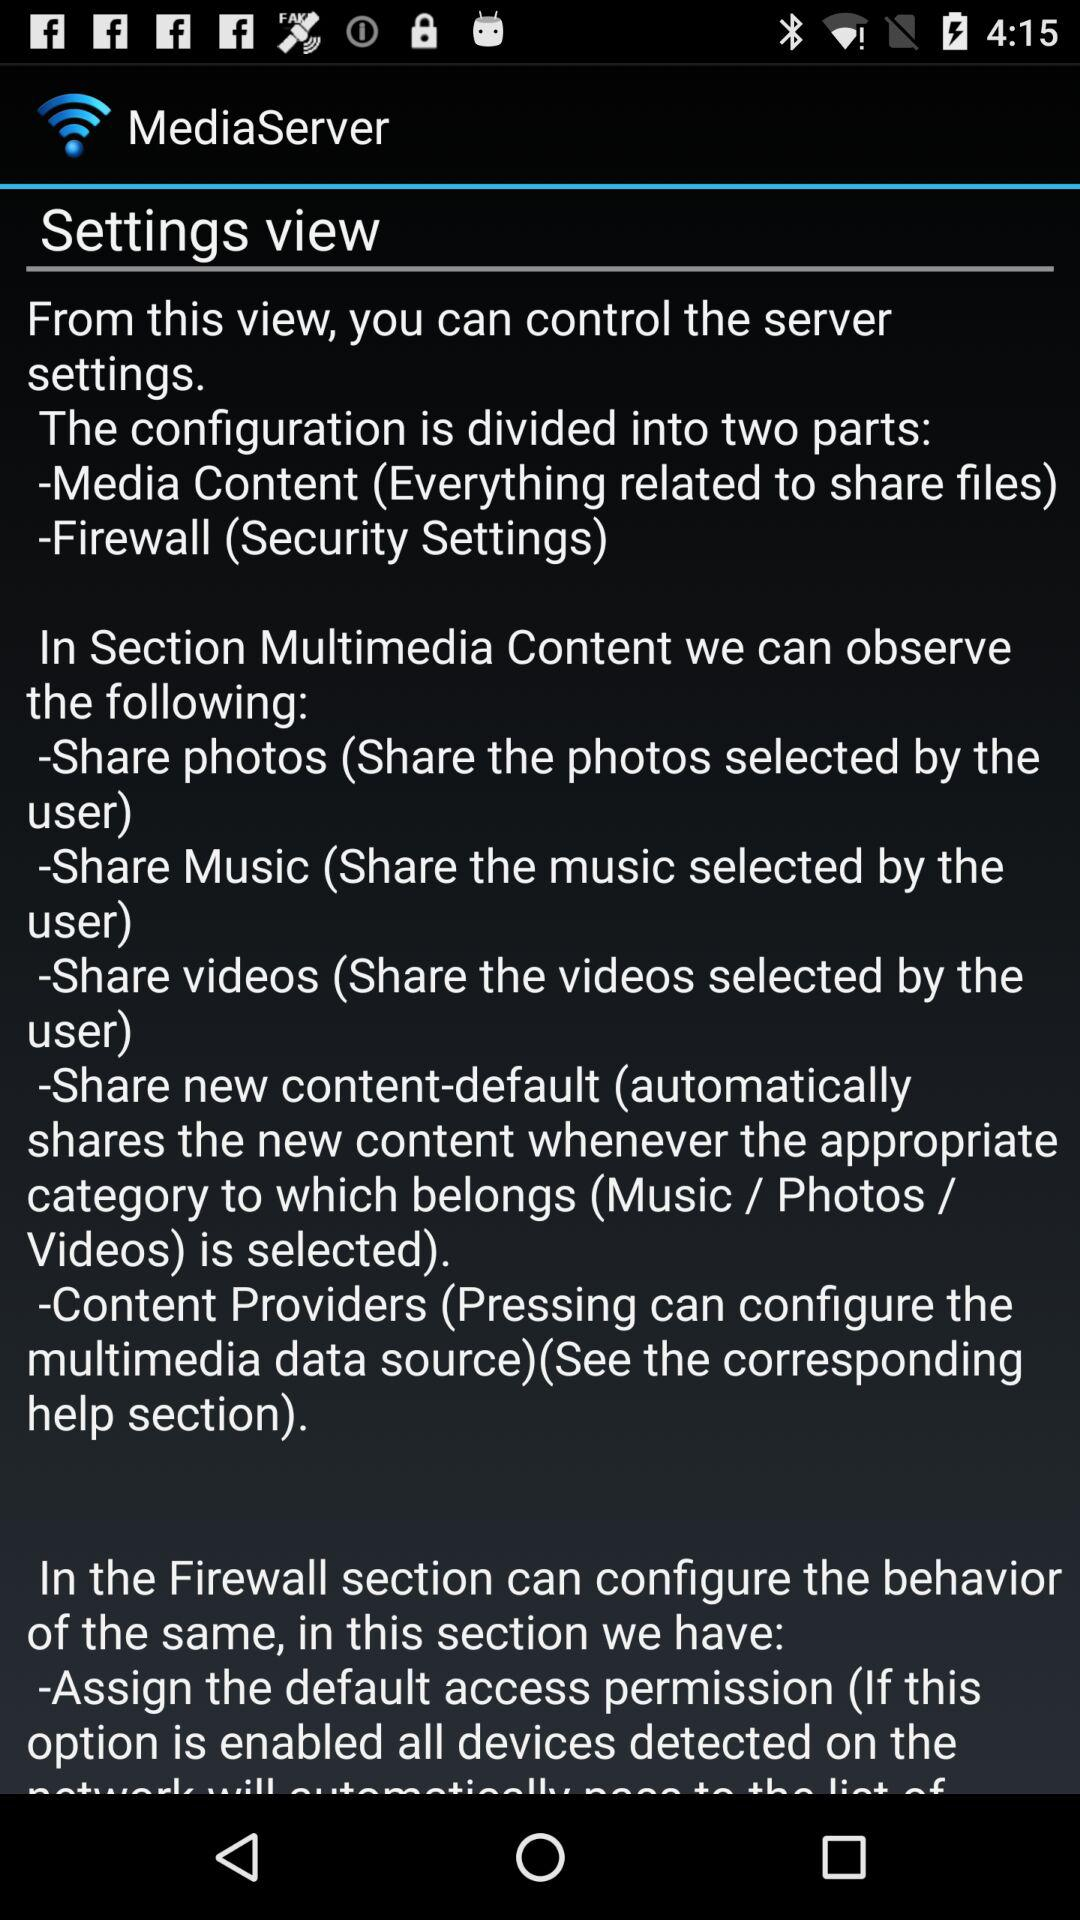How many sections are there in the settings view?
Answer the question using a single word or phrase. 2 